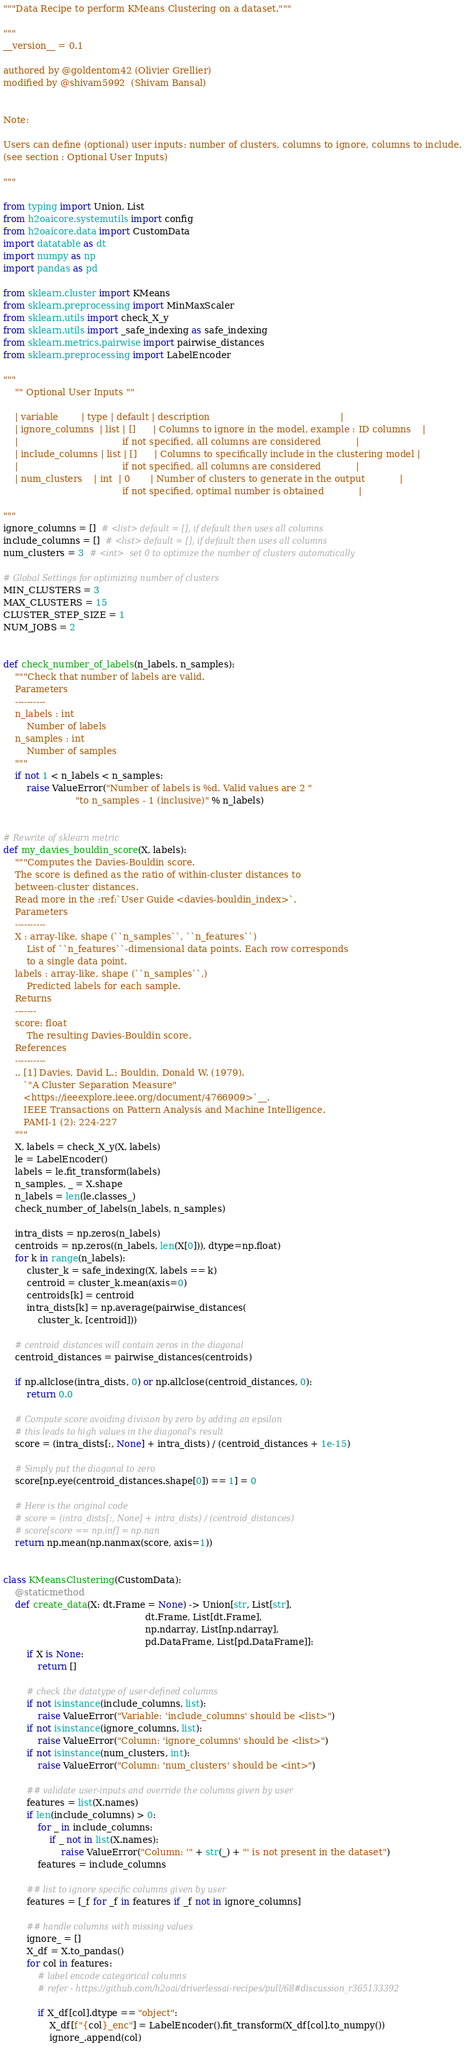Convert code to text. <code><loc_0><loc_0><loc_500><loc_500><_Python_>"""Data Recipe to perform KMeans Clustering on a dataset."""

"""
__version__ = 0.1

authored by @goldentom42 (Olivier Grellier)
modified by @shivam5992  (Shivam Bansal)


Note:

Users can define (optional) user inputs: number of clusters, columns to ignore, columns to include. 
(see section : Optional User Inputs)

"""

from typing import Union, List
from h2oaicore.systemutils import config
from h2oaicore.data import CustomData
import datatable as dt
import numpy as np
import pandas as pd

from sklearn.cluster import KMeans
from sklearn.preprocessing import MinMaxScaler
from sklearn.utils import check_X_y
from sklearn.utils import _safe_indexing as safe_indexing
from sklearn.metrics.pairwise import pairwise_distances
from sklearn.preprocessing import LabelEncoder

""" 
	"" Optional User Inputs "" 

	| variable        | type | default | description                                             |
	| ignore_columns  | list | []      | Columns to ignore in the model, example : ID columns    |
	|                                    if not specified, all columns are considered            | 
	| include_columns | list | []      | Columns to specifically include in the clustering model | 
	|                                    if not specified, all columns are considered            |
	| num_clusters    | int  | 0       | Number of clusters to generate in the output            | 
										 if not specified, optimal number is obtained            | 

"""
ignore_columns = []  # <list> default = [], if default then uses all columns
include_columns = []  # <list> default = [], if default then uses all columns
num_clusters = 3  # <int>  set 0 to optimize the number of clusters automatically

# Global Settings for optimizing number of clusters
MIN_CLUSTERS = 3
MAX_CLUSTERS = 15
CLUSTER_STEP_SIZE = 1
NUM_JOBS = 2


def check_number_of_labels(n_labels, n_samples):
    """Check that number of labels are valid.
    Parameters
    ----------
    n_labels : int
        Number of labels
    n_samples : int
        Number of samples
    """
    if not 1 < n_labels < n_samples:
        raise ValueError("Number of labels is %d. Valid values are 2 "
                         "to n_samples - 1 (inclusive)" % n_labels)


# Rewrite of sklearn metric
def my_davies_bouldin_score(X, labels):
    """Computes the Davies-Bouldin score.
    The score is defined as the ratio of within-cluster distances to
    between-cluster distances.
    Read more in the :ref:`User Guide <davies-bouldin_index>`.
    Parameters
    ----------
    X : array-like, shape (``n_samples``, ``n_features``)
        List of ``n_features``-dimensional data points. Each row corresponds
        to a single data point.
    labels : array-like, shape (``n_samples``,)
        Predicted labels for each sample.
    Returns
    -------
    score: float
        The resulting Davies-Bouldin score.
    References
    ----------
    .. [1] Davies, David L.; Bouldin, Donald W. (1979).
       `"A Cluster Separation Measure"
       <https://ieeexplore.ieee.org/document/4766909>`__.
       IEEE Transactions on Pattern Analysis and Machine Intelligence.
       PAMI-1 (2): 224-227
    """
    X, labels = check_X_y(X, labels)
    le = LabelEncoder()
    labels = le.fit_transform(labels)
    n_samples, _ = X.shape
    n_labels = len(le.classes_)
    check_number_of_labels(n_labels, n_samples)

    intra_dists = np.zeros(n_labels)
    centroids = np.zeros((n_labels, len(X[0])), dtype=np.float)
    for k in range(n_labels):
        cluster_k = safe_indexing(X, labels == k)
        centroid = cluster_k.mean(axis=0)
        centroids[k] = centroid
        intra_dists[k] = np.average(pairwise_distances(
            cluster_k, [centroid]))

    # centroid_distances will contain zeros in the diagonal
    centroid_distances = pairwise_distances(centroids)

    if np.allclose(intra_dists, 0) or np.allclose(centroid_distances, 0):
        return 0.0

    # Compute score avoiding division by zero by adding an epsilon
    # this leads to high values in the diagonal's result
    score = (intra_dists[:, None] + intra_dists) / (centroid_distances + 1e-15)

    # Simply put the diagonal to zero
    score[np.eye(centroid_distances.shape[0]) == 1] = 0

    # Here is the original code
    # score = (intra_dists[:, None] + intra_dists) / (centroid_distances)
    # score[score == np.inf] = np.nan
    return np.mean(np.nanmax(score, axis=1))


class KMeansClustering(CustomData):
    @staticmethod
    def create_data(X: dt.Frame = None) -> Union[str, List[str],
                                                 dt.Frame, List[dt.Frame],
                                                 np.ndarray, List[np.ndarray],
                                                 pd.DataFrame, List[pd.DataFrame]]:
        if X is None:
            return []

        # check the datatype of user-defined columns
        if not isinstance(include_columns, list):
            raise ValueError("Variable: 'include_columns' should be <list>")
        if not isinstance(ignore_columns, list):
            raise ValueError("Column: 'ignore_columns' should be <list>")
        if not isinstance(num_clusters, int):
            raise ValueError("Column: 'num_clusters' should be <int>")

        ## validate user-inputs and override the columns given by user
        features = list(X.names)
        if len(include_columns) > 0:
            for _ in include_columns:
                if _ not in list(X.names):
                    raise ValueError("Column: '" + str(_) + "' is not present in the dataset")
            features = include_columns

        ## list to ignore specific columns given by user
        features = [_f for _f in features if _f not in ignore_columns]

        ## handle columns with missing values 
        ignore_ = []
        X_df = X.to_pandas()
        for col in features:
            # label encode categorical columns
            # refer - https://github.com/h2oai/driverlessai-recipes/pull/68#discussion_r365133392

            if X_df[col].dtype == "object":
                X_df[f"{col}_enc"] = LabelEncoder().fit_transform(X_df[col].to_numpy())
                ignore_.append(col)
</code> 